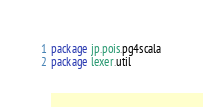Convert code to text. <code><loc_0><loc_0><loc_500><loc_500><_Scala_>package jp.pois.pg4scala
package lexer.util
</code> 